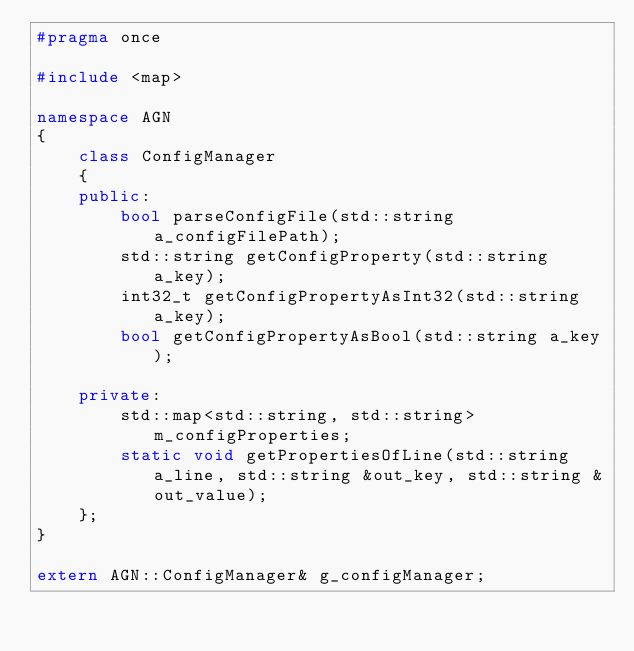Convert code to text. <code><loc_0><loc_0><loc_500><loc_500><_C++_>#pragma once 

#include <map>

namespace AGN
{
	class ConfigManager
	{
	public:
		bool parseConfigFile(std::string a_configFilePath);
		std::string getConfigProperty(std::string a_key);
		int32_t getConfigPropertyAsInt32(std::string a_key);
		bool getConfigPropertyAsBool(std::string a_key);

	private:
		std::map<std::string, std::string> m_configProperties;
		static void getPropertiesOfLine(std::string a_line, std::string &out_key, std::string &out_value);
	};
}

extern AGN::ConfigManager& g_configManager;</code> 